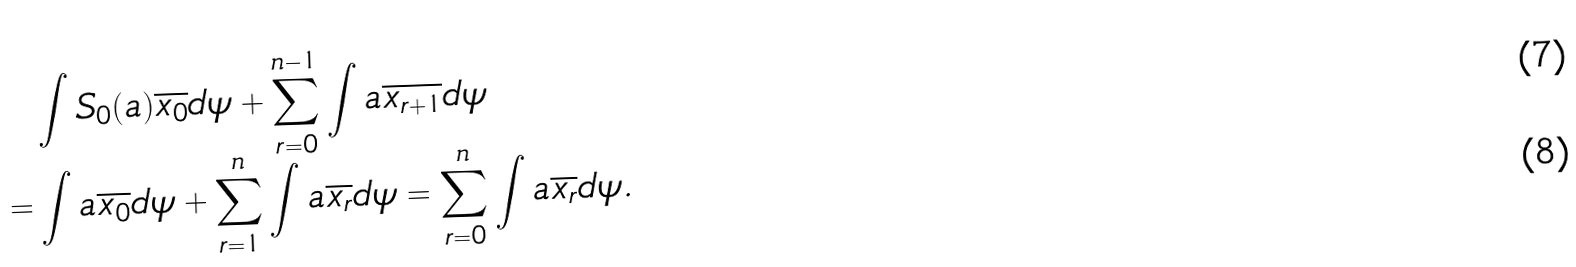Convert formula to latex. <formula><loc_0><loc_0><loc_500><loc_500>& \int S _ { 0 } ( a ) \overline { x _ { 0 } } d \psi + \sum _ { r = 0 } ^ { n - 1 } \int a \overline { x _ { r + 1 } } d \psi \\ = & \int a \overline { x _ { 0 } } d \psi + \sum _ { r = 1 } ^ { n } \int a \overline { x _ { r } } d \psi = \sum _ { r = 0 } ^ { n } \int a \overline { x _ { r } } d \psi .</formula> 